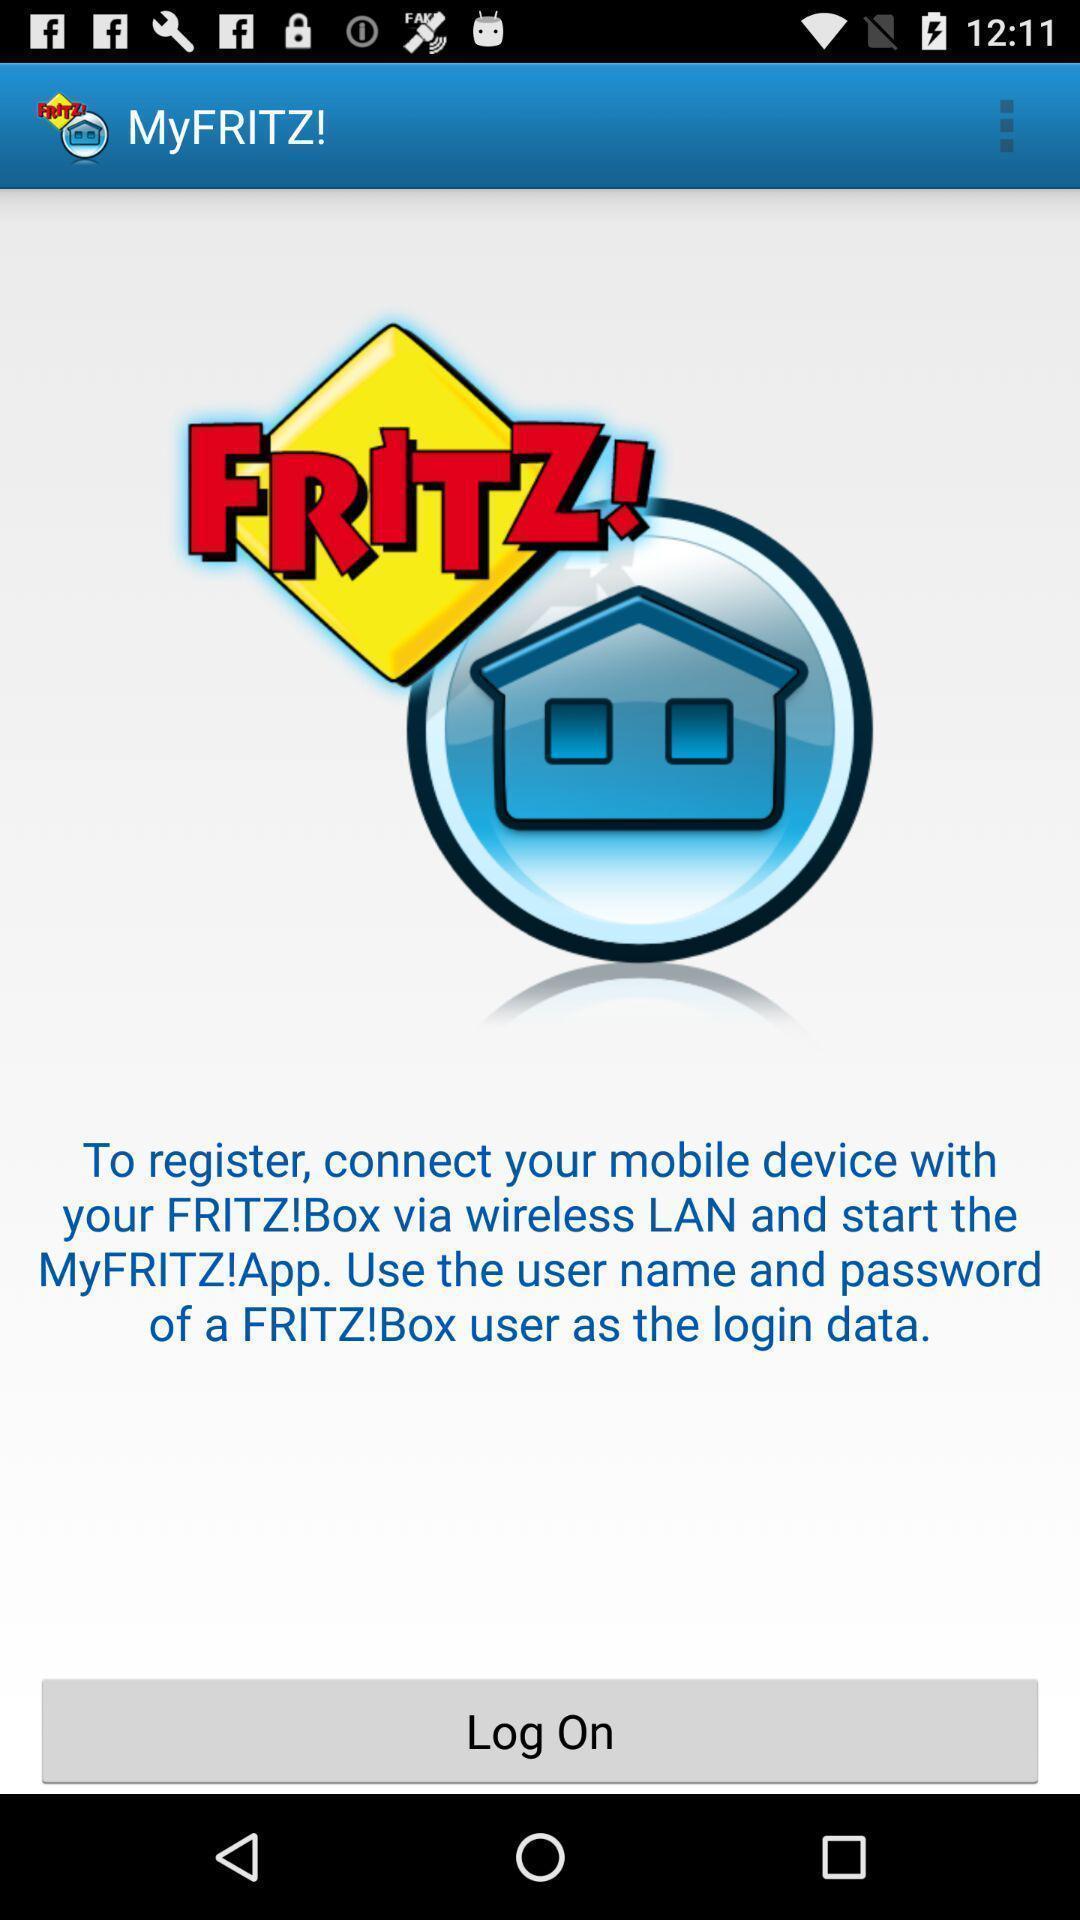Summarize the main components in this picture. Screen displaying login page. 